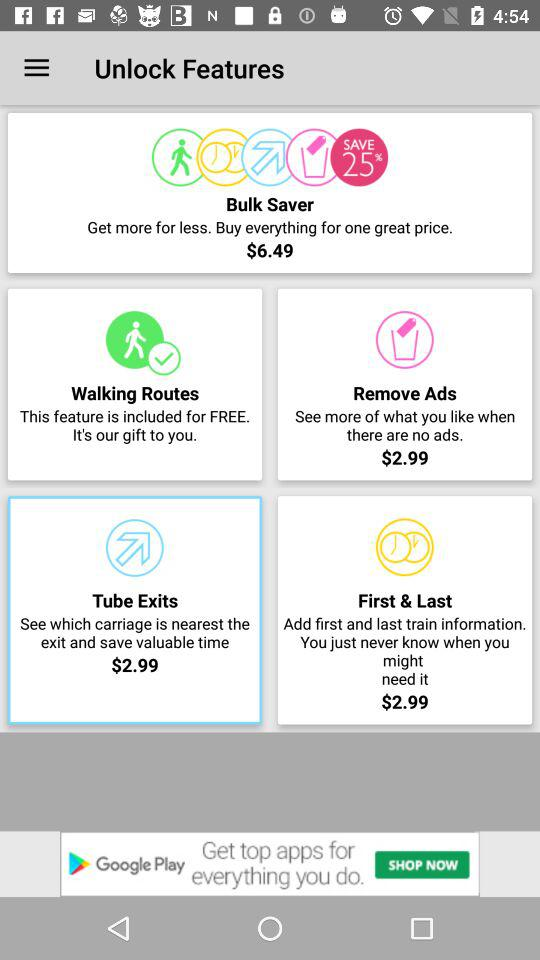What is the price of "Remove Ads"? The price of "Remove Ads" is $2.99. 